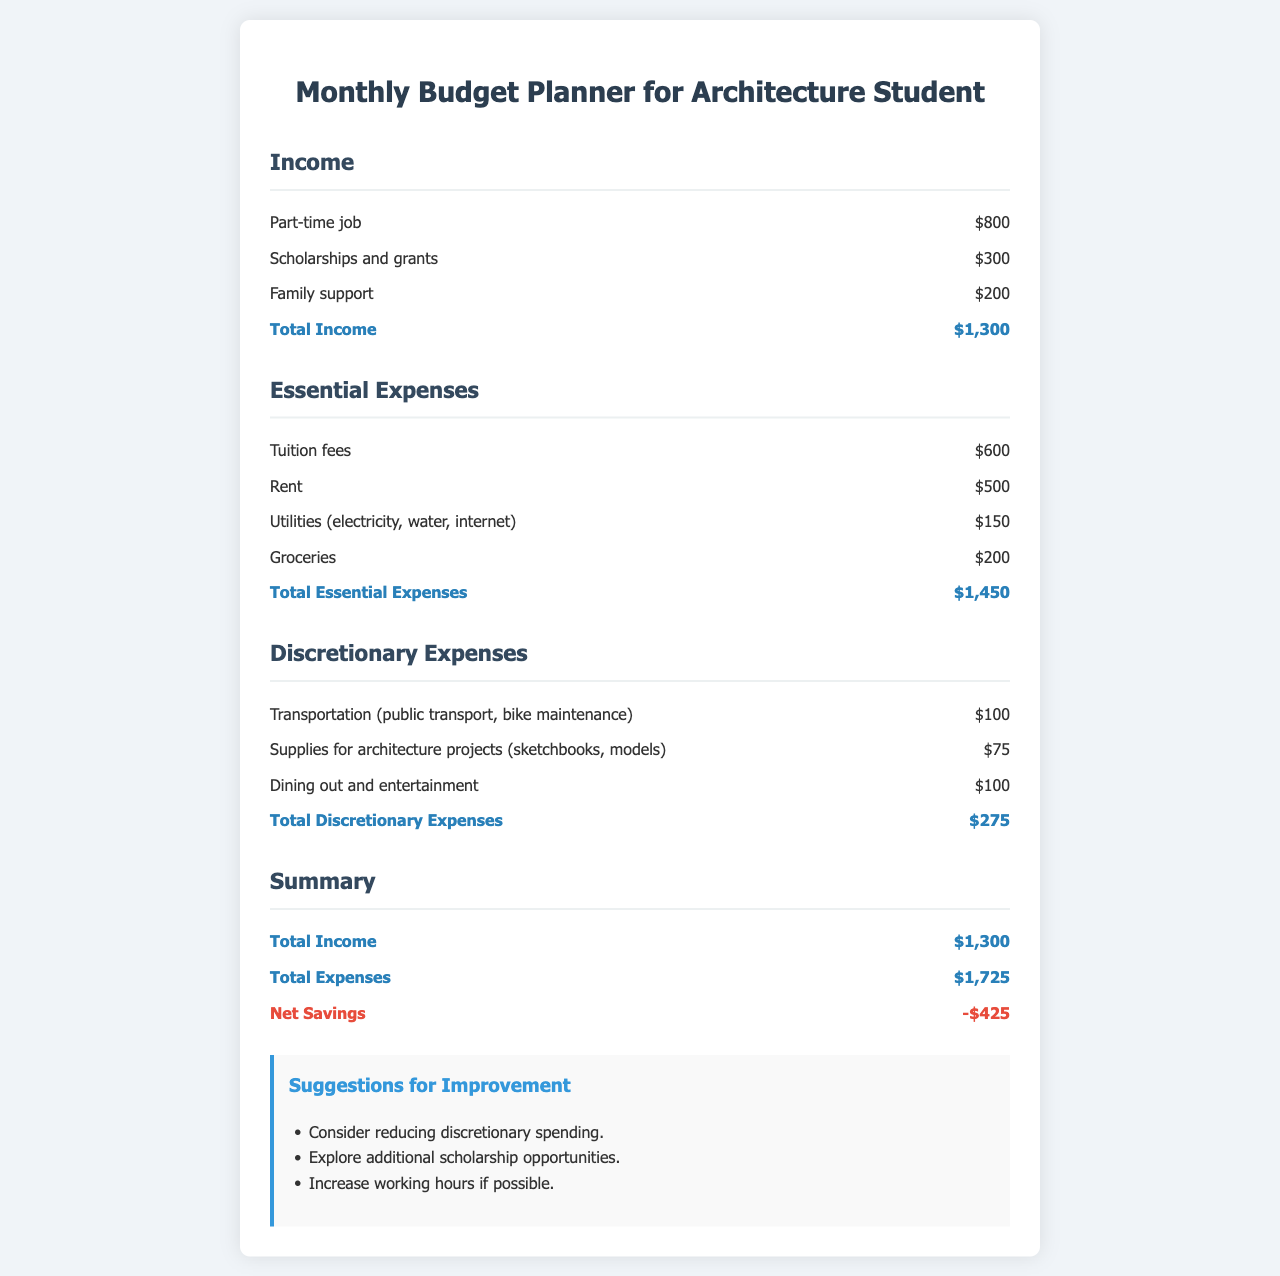What is the total income? The total income is the sum of all income sources: part-time job, scholarships and grants, and family support, which is $800 + $300 + $200 = $1300.
Answer: $1300 What are the essential expenses? The essential expenses include tuition fees, rent, utilities, and groceries, amounting to $600 + $500 + $150 + $200 = $1450.
Answer: $1450 What is the total discretionary expense? The total discretionary expense is the sum of all discretionary items: transportation, supplies, and dining out, which is $100 + $75 + $100 = $275.
Answer: $275 What is the net savings? The net savings is calculated by subtracting total expenses from total income, which is $1300 - $1725 = -$425.
Answer: -$425 Which suggestion involves scholarships? The suggestion regarding scholarships is to explore additional scholarship opportunities.
Answer: Explore additional scholarship opportunities 